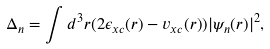<formula> <loc_0><loc_0><loc_500><loc_500>\Delta _ { n } = \int d ^ { 3 } { r } ( 2 \epsilon _ { x c } ( { r } ) - v _ { x c } ( { r } ) ) | \psi _ { n } ( { r } ) | ^ { 2 } ,</formula> 